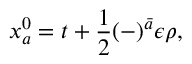<formula> <loc_0><loc_0><loc_500><loc_500>x _ { a } ^ { 0 } = t + \frac { 1 } { 2 } ( - ) ^ { \bar { a } } \epsilon \rho ,</formula> 